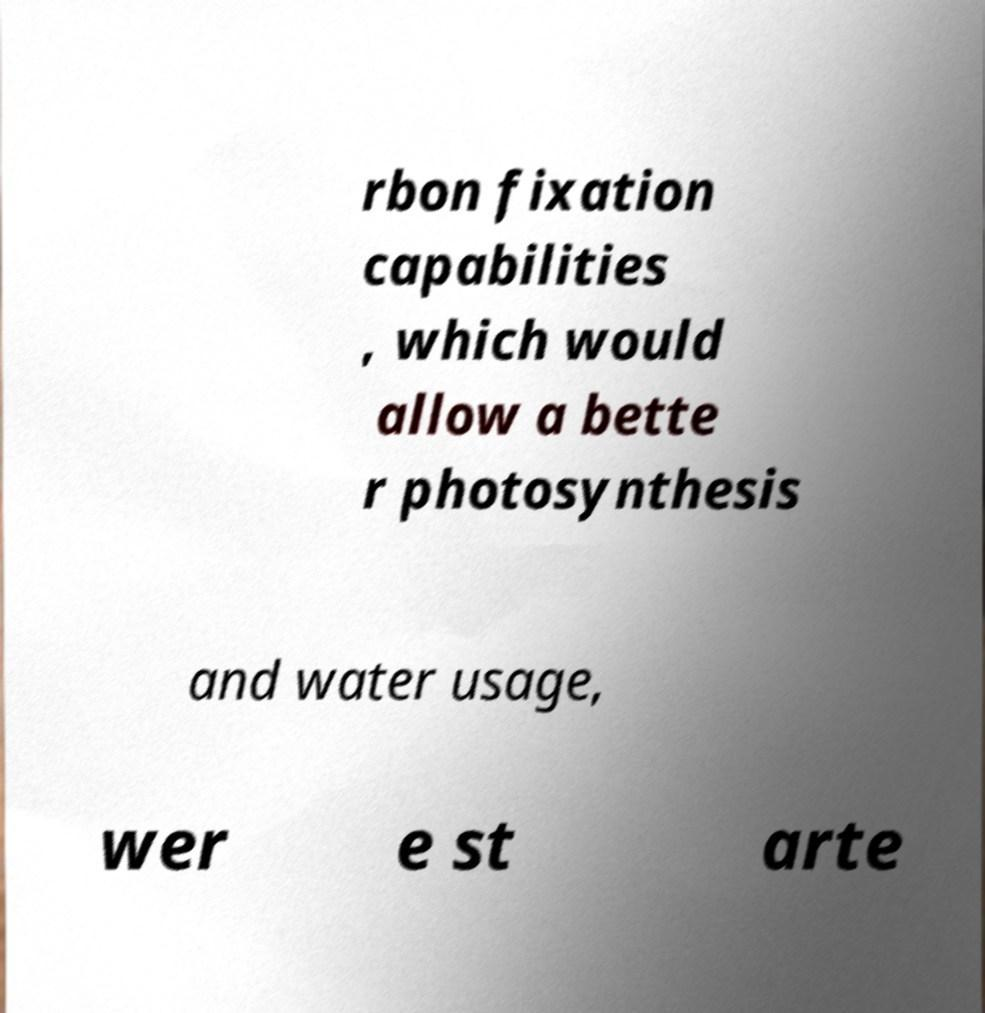Please identify and transcribe the text found in this image. rbon fixation capabilities , which would allow a bette r photosynthesis and water usage, wer e st arte 